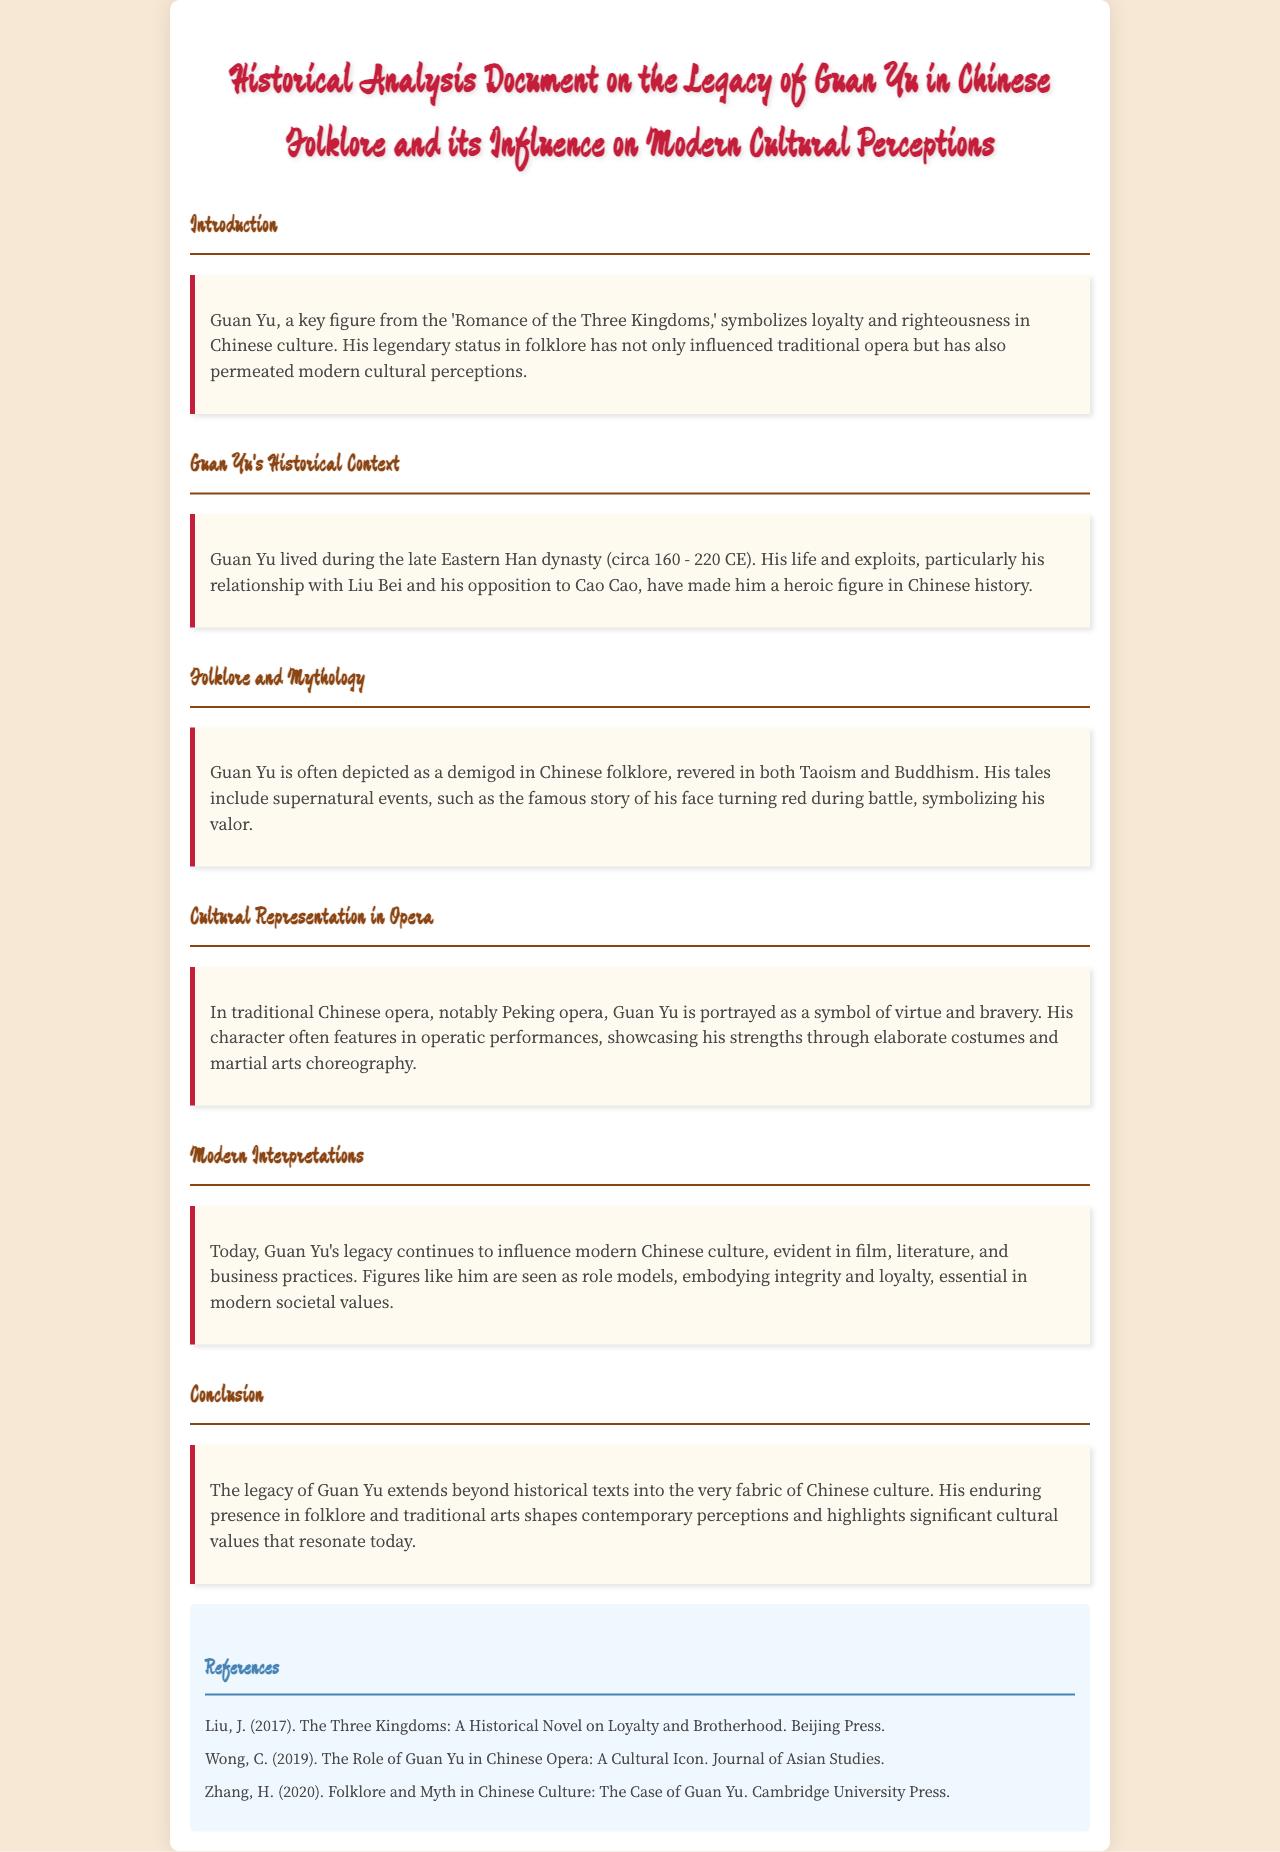What is the title of the document? The title is mentioned in the first section of the document, summarizing its focus.
Answer: Historical Analysis Document on the Legacy of Guan Yu in Chinese Folklore and its Influence on Modern Cultural Perceptions Who is a key figure in the 'Romance of the Three Kingdoms'? The document states that Guan Yu is a key figure in this historical narrative.
Answer: Guan Yu During which dynasty did Guan Yu live? The document specifies the time period in which Guan Yu's life took place.
Answer: Eastern Han dynasty In which cultural expressions is Guan Yu's character prominently featured? The document discusses the portrayal of Guan Yu in various artistic forms like opera.
Answer: Traditional Chinese opera What quality does Guan Yu symbolize in Chinese culture? The document emphasizes the symbolic representation associated with Guan Yu.
Answer: Loyalty and righteousness What is one modern cultural influence of Guan Yu mentioned? The document outlines the impact of Guan Yu on contemporary societal values.
Answer: Role models Who wrote about the role of Guan Yu in Chinese opera? The reference section attributes a particular contribution to a specific author and journal.
Answer: Wong, C What color scheme is used for the document’s headings? The document describes the specific colors used in its design.
Answer: Red and brown What type of legacy does Guan Yu have according to the conclusion? The conclusion summarizes the overall impact of Guan Yu's legacy in cultural contexts.
Answer: Enduring presence 